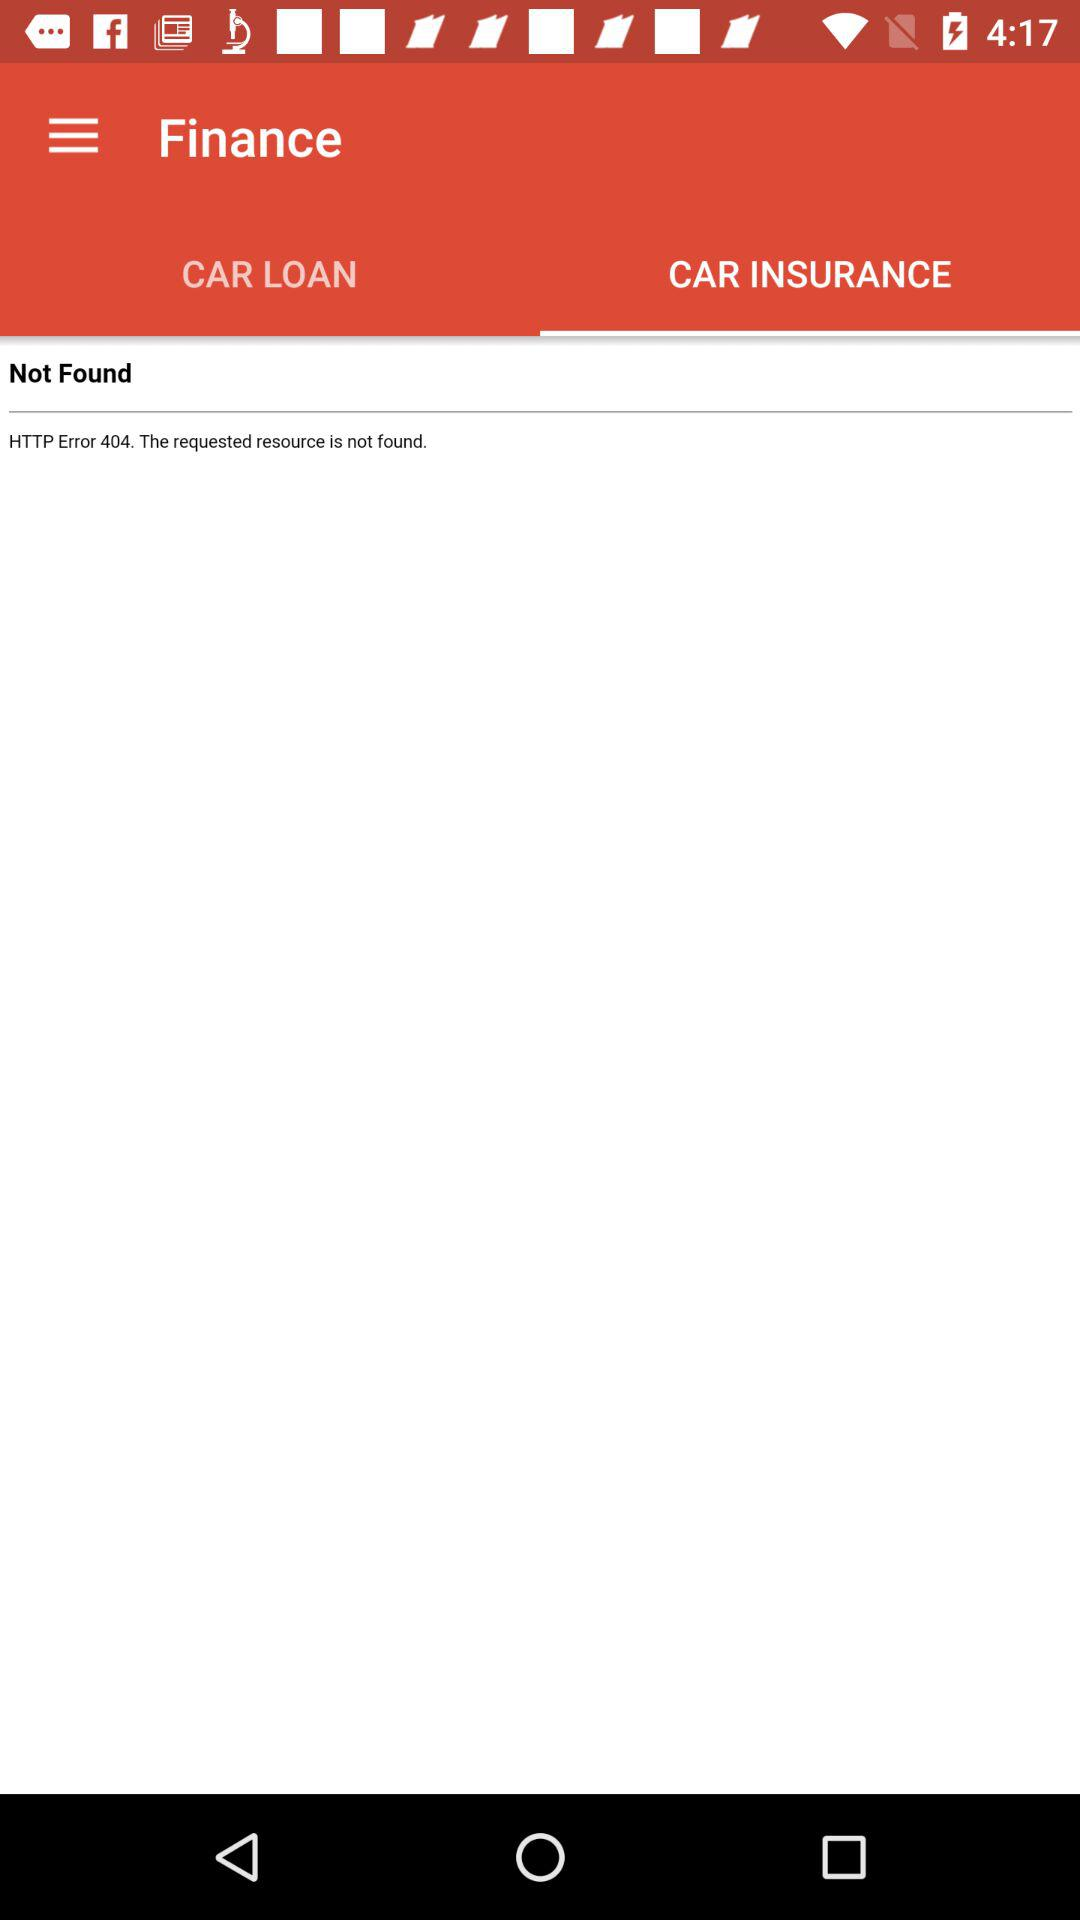Which option is selected in "Finance"? The selected option is "CAR INSURANCE". 